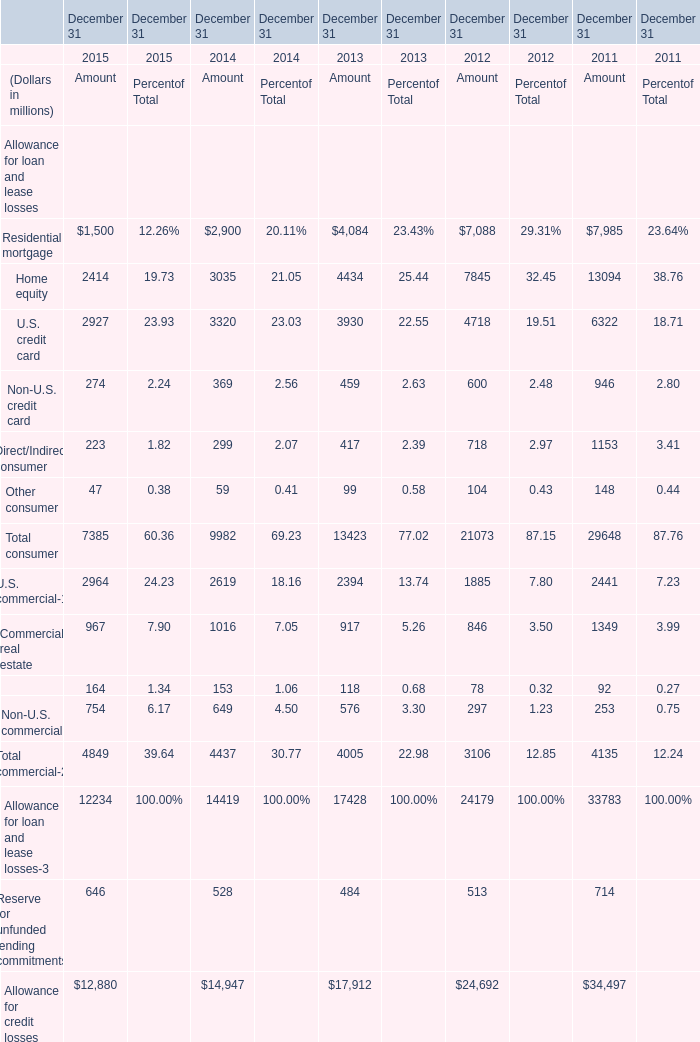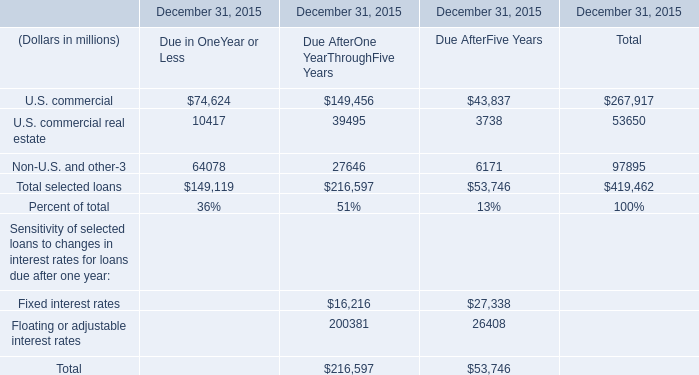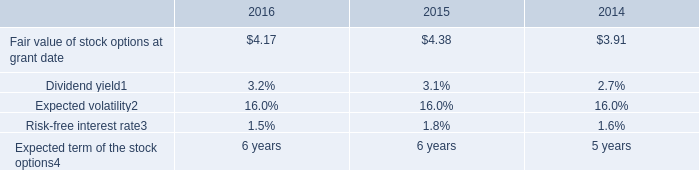What is the ratio of U.S. credit card of Amount in Table 0 to the Non-U.S. and other of Due After Five Years in Table 1 in 2015? 
Computations: (2927 / 6171)
Answer: 0.47432. 